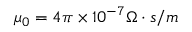Convert formula to latex. <formula><loc_0><loc_0><loc_500><loc_500>\mu _ { 0 } = 4 \pi \times 1 0 ^ { - 7 } \Omega \cdot s / m</formula> 